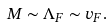Convert formula to latex. <formula><loc_0><loc_0><loc_500><loc_500>M \sim \Lambda _ { F } \sim v _ { F } .</formula> 